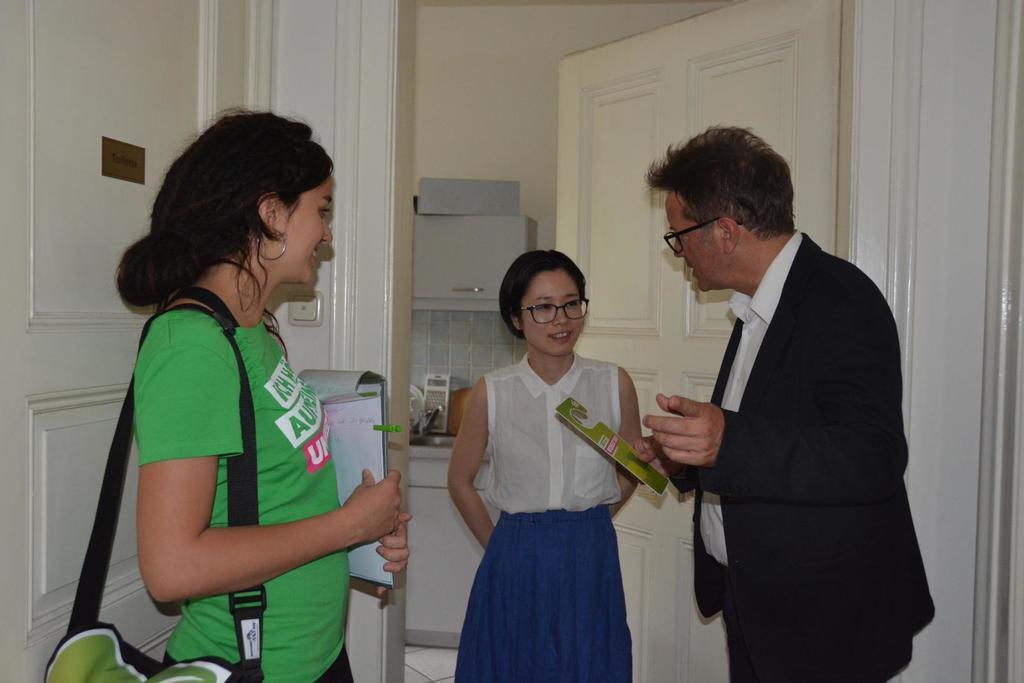In one or two sentences, can you explain what this image depicts? There are three people standing, she is carrying a bag and holding papers with board and he is holding a card. We can see doors. In the background we can see objects and sink with tap on the surface, cupboard and wall. 